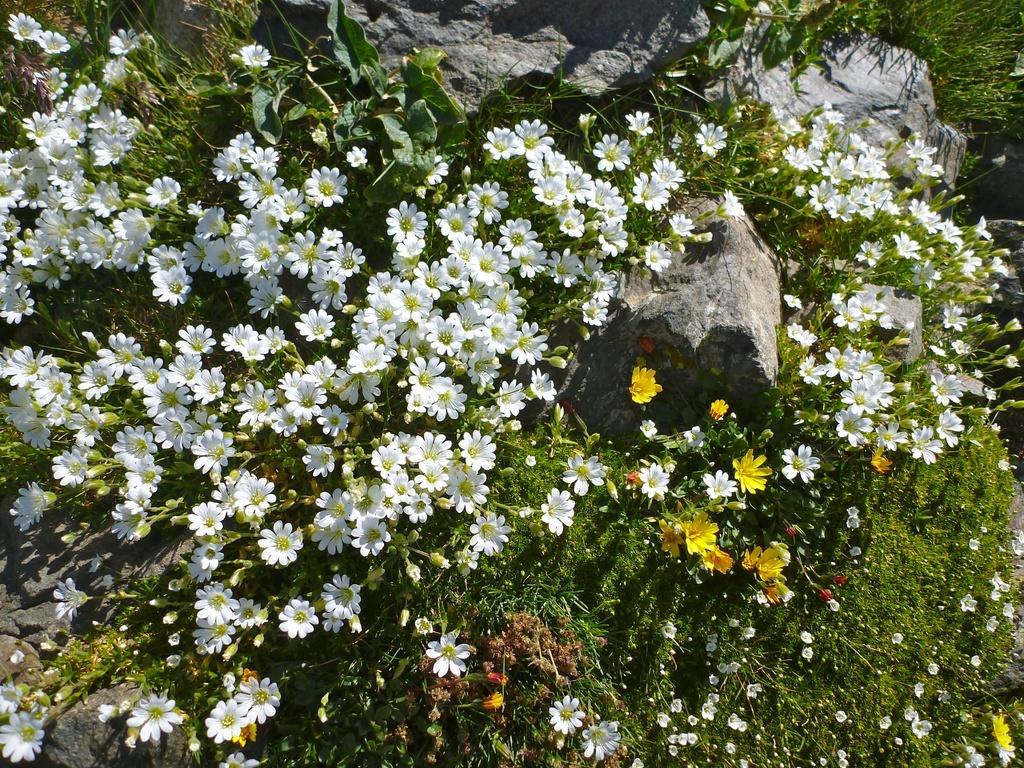Describe this image in one or two sentences. Here we can see plants, flowers, and buds. There are rocks. 